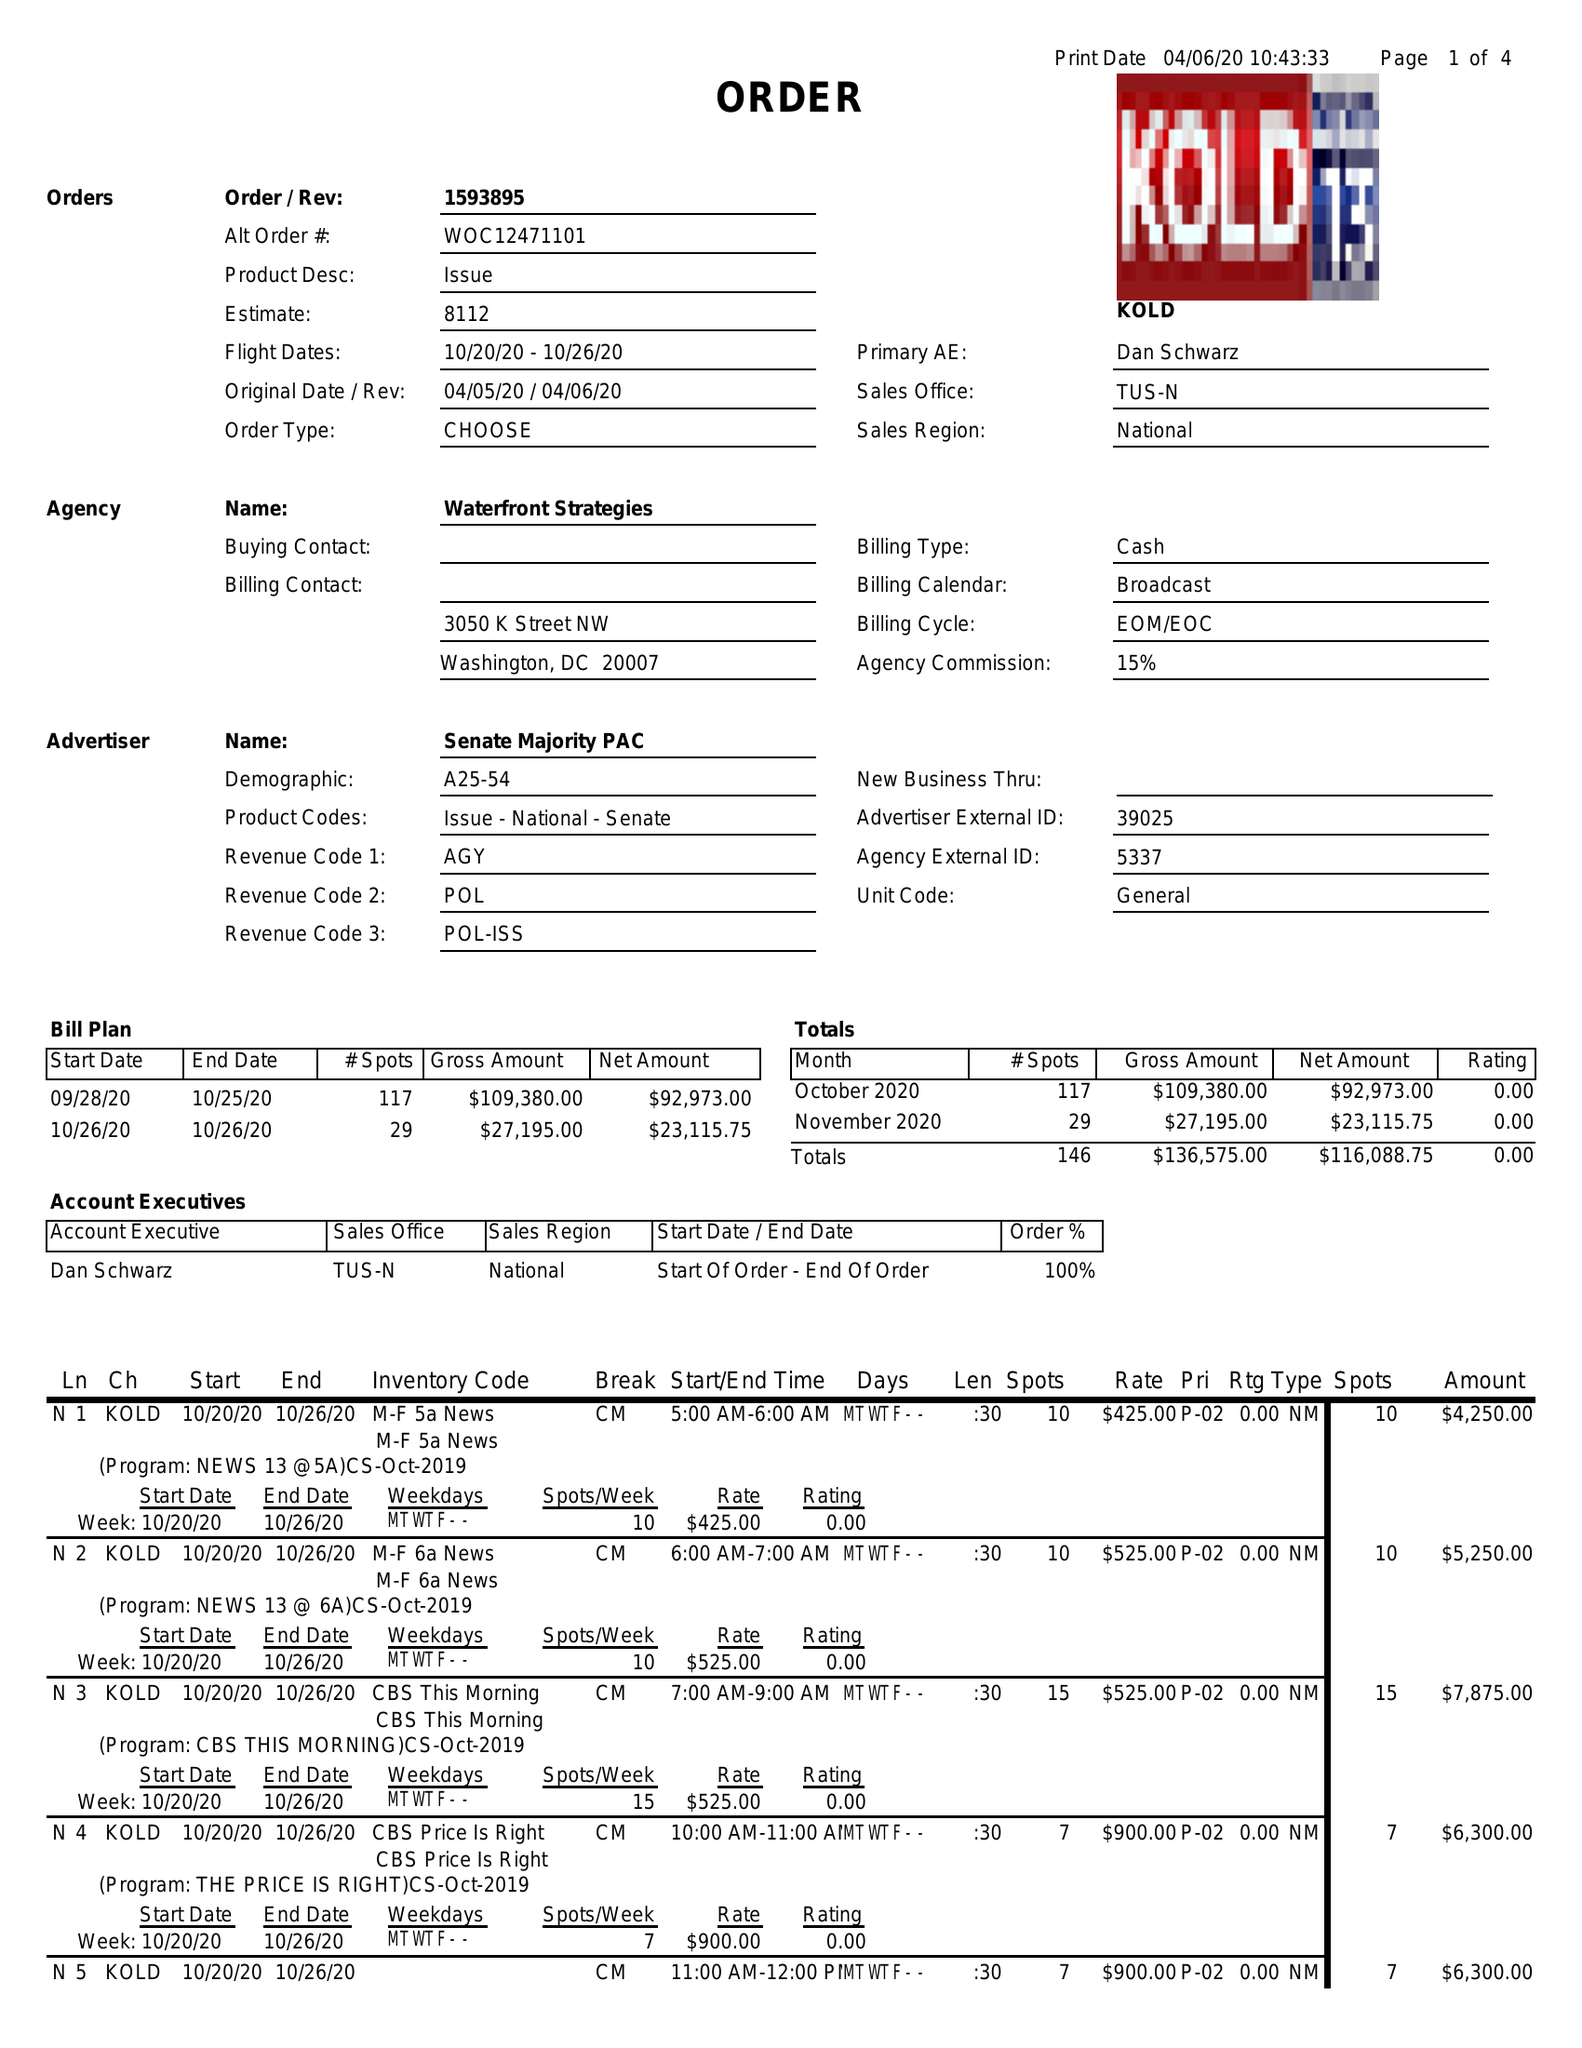What is the value for the contract_num?
Answer the question using a single word or phrase. 1593895 